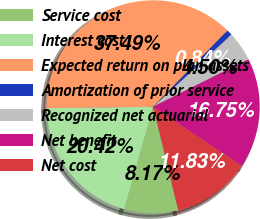<chart> <loc_0><loc_0><loc_500><loc_500><pie_chart><fcel>Service cost<fcel>Interest cost<fcel>Expected return on plan assets<fcel>Amortization of prior service<fcel>Recognized net actuarial<fcel>Net benefit<fcel>Net cost<nl><fcel>8.17%<fcel>20.42%<fcel>37.49%<fcel>0.84%<fcel>4.5%<fcel>16.75%<fcel>11.83%<nl></chart> 